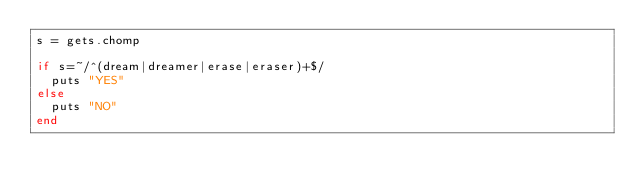<code> <loc_0><loc_0><loc_500><loc_500><_Ruby_>s = gets.chomp

if s=~/^(dream|dreamer|erase|eraser)+$/
  puts "YES"
else 
  puts "NO"
end
</code> 